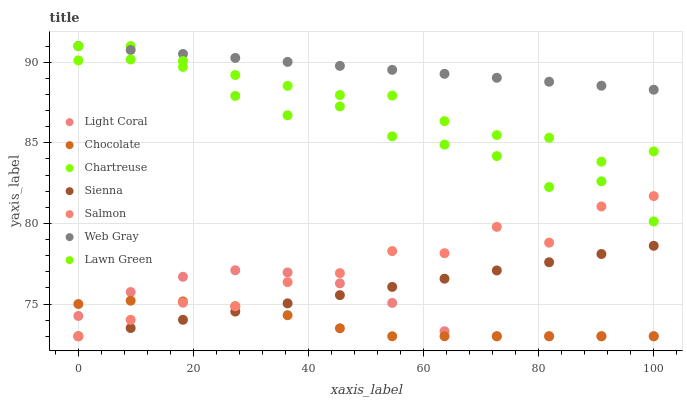Does Chocolate have the minimum area under the curve?
Answer yes or no. Yes. Does Web Gray have the maximum area under the curve?
Answer yes or no. Yes. Does Lawn Green have the minimum area under the curve?
Answer yes or no. No. Does Lawn Green have the maximum area under the curve?
Answer yes or no. No. Is Web Gray the smoothest?
Answer yes or no. Yes. Is Lawn Green the roughest?
Answer yes or no. Yes. Is Lawn Green the smoothest?
Answer yes or no. No. Is Web Gray the roughest?
Answer yes or no. No. Does Sienna have the lowest value?
Answer yes or no. Yes. Does Lawn Green have the lowest value?
Answer yes or no. No. Does Chartreuse have the highest value?
Answer yes or no. Yes. Does Salmon have the highest value?
Answer yes or no. No. Is Chocolate less than Chartreuse?
Answer yes or no. Yes. Is Chartreuse greater than Light Coral?
Answer yes or no. Yes. Does Chocolate intersect Light Coral?
Answer yes or no. Yes. Is Chocolate less than Light Coral?
Answer yes or no. No. Is Chocolate greater than Light Coral?
Answer yes or no. No. Does Chocolate intersect Chartreuse?
Answer yes or no. No. 